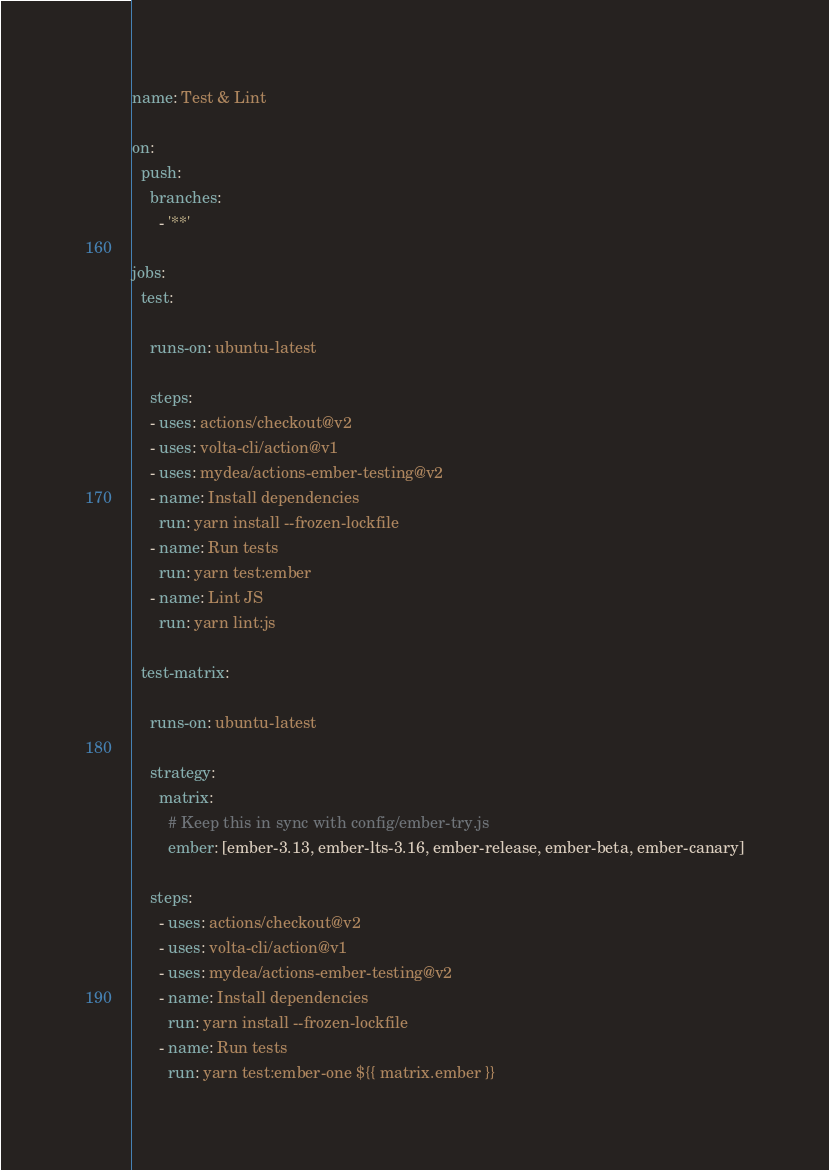<code> <loc_0><loc_0><loc_500><loc_500><_YAML_>name: Test & Lint

on:
  push:
    branches:
      - '**'

jobs:
  test:

    runs-on: ubuntu-latest

    steps:
    - uses: actions/checkout@v2
    - uses: volta-cli/action@v1
    - uses: mydea/actions-ember-testing@v2
    - name: Install dependencies
      run: yarn install --frozen-lockfile
    - name: Run tests
      run: yarn test:ember
    - name: Lint JS
      run: yarn lint:js

  test-matrix:

    runs-on: ubuntu-latest

    strategy:
      matrix:
        # Keep this in sync with config/ember-try.js
        ember: [ember-3.13, ember-lts-3.16, ember-release, ember-beta, ember-canary]

    steps:
      - uses: actions/checkout@v2
      - uses: volta-cli/action@v1
      - uses: mydea/actions-ember-testing@v2
      - name: Install dependencies
        run: yarn install --frozen-lockfile
      - name: Run tests
        run: yarn test:ember-one ${{ matrix.ember }}
</code> 